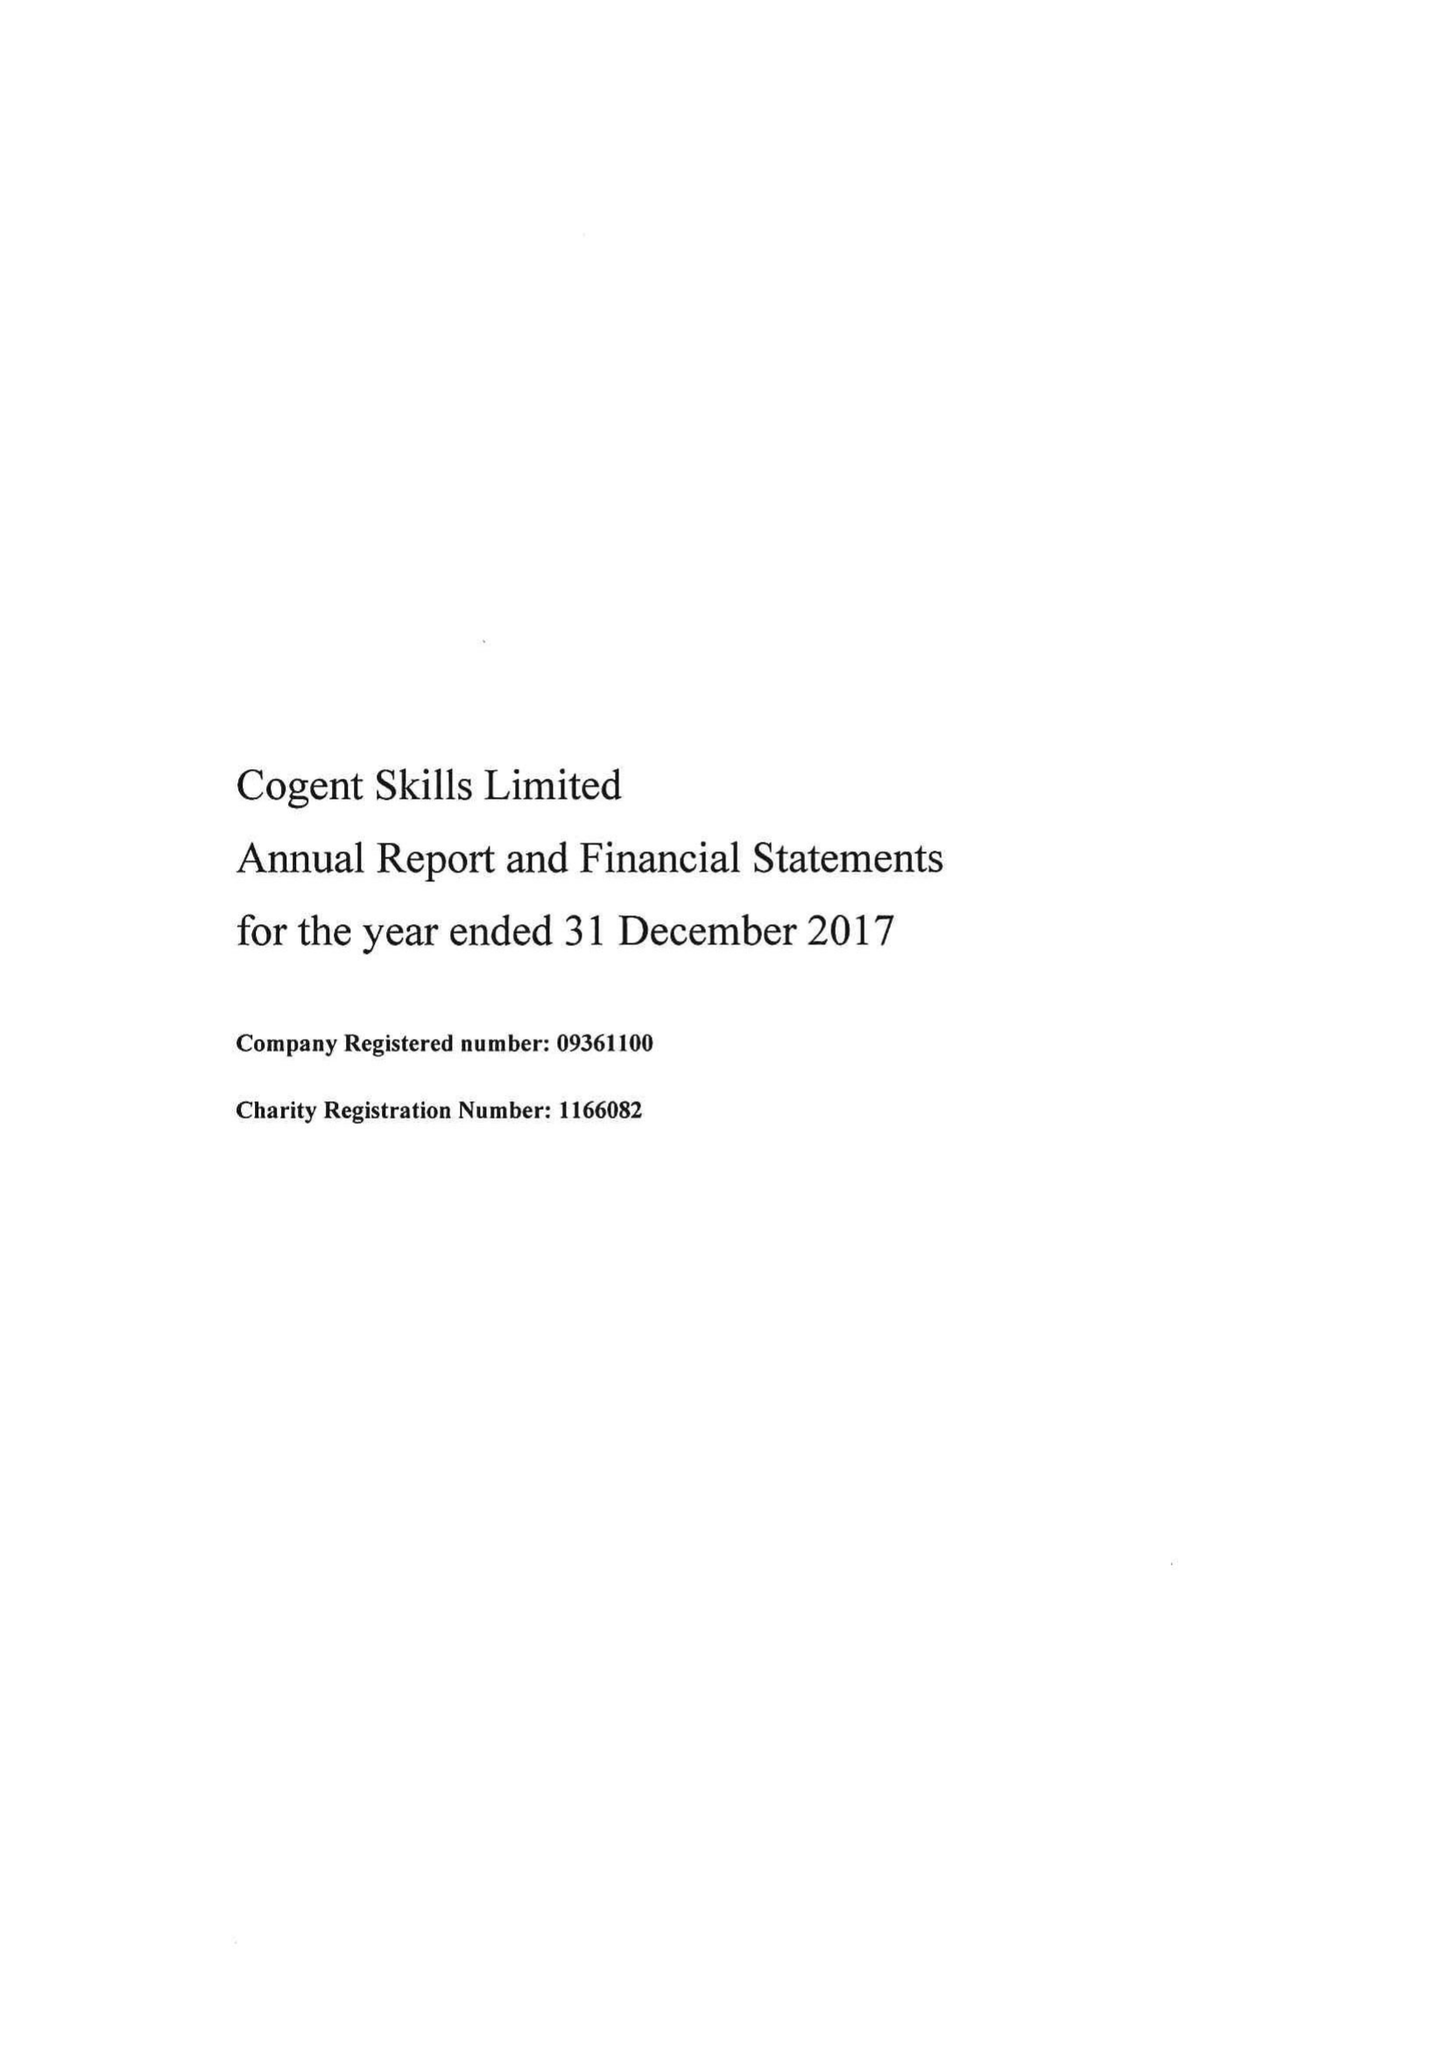What is the value for the spending_annually_in_british_pounds?
Answer the question using a single word or phrase. 12539000.00 